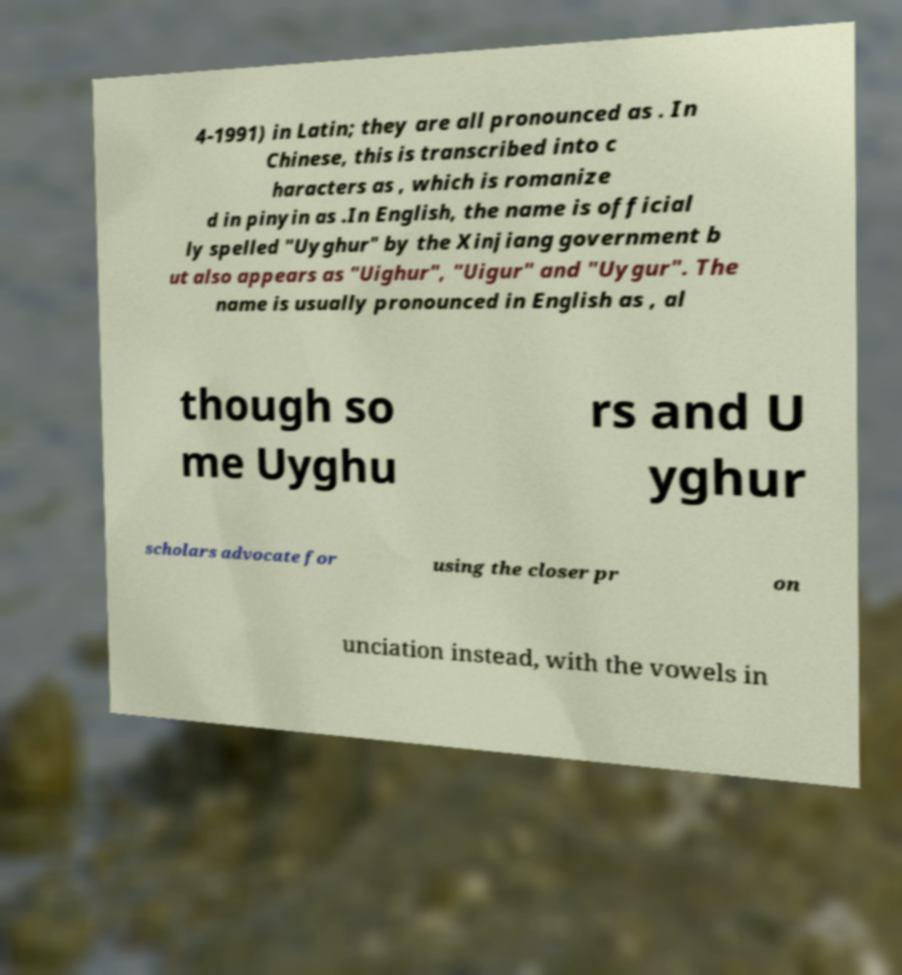Could you assist in decoding the text presented in this image and type it out clearly? 4-1991) in Latin; they are all pronounced as . In Chinese, this is transcribed into c haracters as , which is romanize d in pinyin as .In English, the name is official ly spelled "Uyghur" by the Xinjiang government b ut also appears as "Uighur", "Uigur" and "Uygur". The name is usually pronounced in English as , al though so me Uyghu rs and U yghur scholars advocate for using the closer pr on unciation instead, with the vowels in 